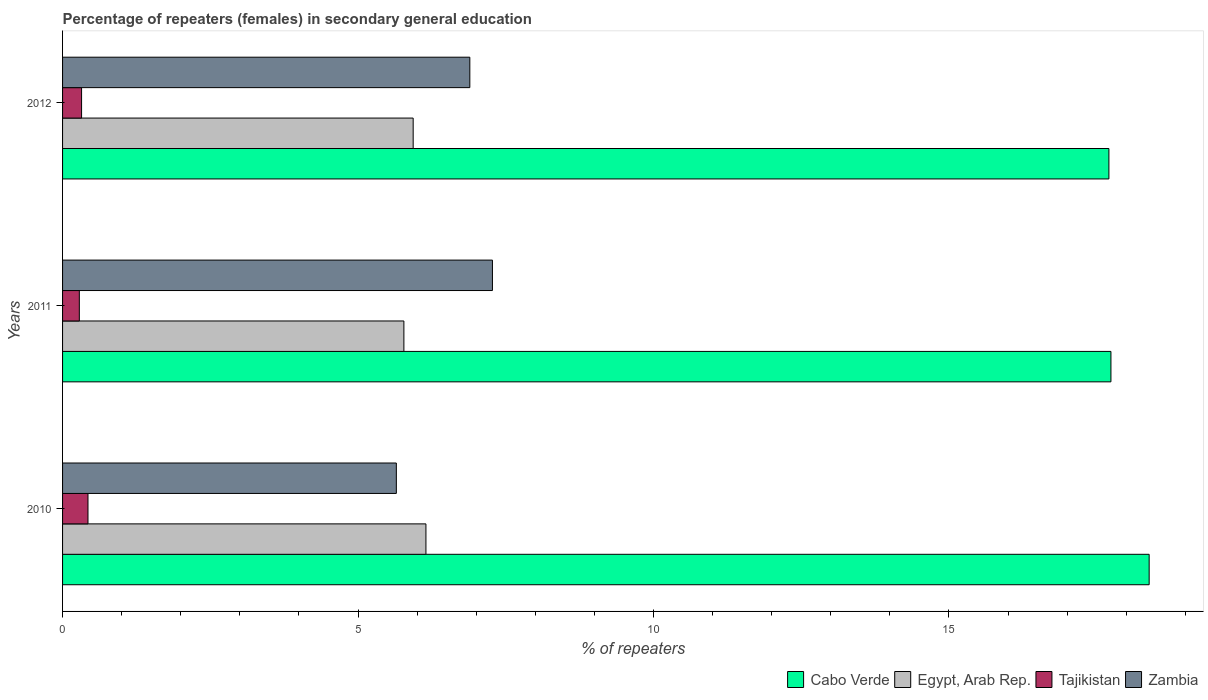How many groups of bars are there?
Make the answer very short. 3. Are the number of bars per tick equal to the number of legend labels?
Give a very brief answer. Yes. In how many cases, is the number of bars for a given year not equal to the number of legend labels?
Your answer should be compact. 0. What is the percentage of female repeaters in Cabo Verde in 2011?
Offer a very short reply. 17.74. Across all years, what is the maximum percentage of female repeaters in Tajikistan?
Your response must be concise. 0.43. Across all years, what is the minimum percentage of female repeaters in Egypt, Arab Rep.?
Provide a short and direct response. 5.78. What is the total percentage of female repeaters in Tajikistan in the graph?
Your answer should be compact. 1.04. What is the difference between the percentage of female repeaters in Tajikistan in 2010 and that in 2011?
Provide a succinct answer. 0.15. What is the difference between the percentage of female repeaters in Egypt, Arab Rep. in 2010 and the percentage of female repeaters in Zambia in 2012?
Your answer should be compact. -0.74. What is the average percentage of female repeaters in Tajikistan per year?
Provide a succinct answer. 0.35. In the year 2011, what is the difference between the percentage of female repeaters in Egypt, Arab Rep. and percentage of female repeaters in Tajikistan?
Your answer should be compact. 5.49. In how many years, is the percentage of female repeaters in Tajikistan greater than 14 %?
Ensure brevity in your answer.  0. What is the ratio of the percentage of female repeaters in Cabo Verde in 2010 to that in 2011?
Provide a succinct answer. 1.04. Is the percentage of female repeaters in Tajikistan in 2010 less than that in 2011?
Give a very brief answer. No. Is the difference between the percentage of female repeaters in Egypt, Arab Rep. in 2011 and 2012 greater than the difference between the percentage of female repeaters in Tajikistan in 2011 and 2012?
Your response must be concise. No. What is the difference between the highest and the second highest percentage of female repeaters in Tajikistan?
Offer a very short reply. 0.11. What is the difference between the highest and the lowest percentage of female repeaters in Zambia?
Your answer should be compact. 1.63. In how many years, is the percentage of female repeaters in Cabo Verde greater than the average percentage of female repeaters in Cabo Verde taken over all years?
Give a very brief answer. 1. Is it the case that in every year, the sum of the percentage of female repeaters in Egypt, Arab Rep. and percentage of female repeaters in Zambia is greater than the sum of percentage of female repeaters in Cabo Verde and percentage of female repeaters in Tajikistan?
Your answer should be compact. Yes. What does the 3rd bar from the top in 2012 represents?
Ensure brevity in your answer.  Egypt, Arab Rep. What does the 3rd bar from the bottom in 2012 represents?
Your answer should be very brief. Tajikistan. Is it the case that in every year, the sum of the percentage of female repeaters in Tajikistan and percentage of female repeaters in Cabo Verde is greater than the percentage of female repeaters in Egypt, Arab Rep.?
Your response must be concise. Yes. How many bars are there?
Offer a very short reply. 12. How many years are there in the graph?
Your answer should be compact. 3. What is the difference between two consecutive major ticks on the X-axis?
Ensure brevity in your answer.  5. Are the values on the major ticks of X-axis written in scientific E-notation?
Your answer should be compact. No. Does the graph contain any zero values?
Provide a succinct answer. No. What is the title of the graph?
Offer a terse response. Percentage of repeaters (females) in secondary general education. Does "European Union" appear as one of the legend labels in the graph?
Keep it short and to the point. No. What is the label or title of the X-axis?
Your answer should be very brief. % of repeaters. What is the label or title of the Y-axis?
Provide a succinct answer. Years. What is the % of repeaters in Cabo Verde in 2010?
Offer a very short reply. 18.39. What is the % of repeaters in Egypt, Arab Rep. in 2010?
Make the answer very short. 6.15. What is the % of repeaters in Tajikistan in 2010?
Make the answer very short. 0.43. What is the % of repeaters in Zambia in 2010?
Provide a short and direct response. 5.65. What is the % of repeaters of Cabo Verde in 2011?
Keep it short and to the point. 17.74. What is the % of repeaters in Egypt, Arab Rep. in 2011?
Your answer should be compact. 5.78. What is the % of repeaters in Tajikistan in 2011?
Your response must be concise. 0.28. What is the % of repeaters in Zambia in 2011?
Offer a terse response. 7.27. What is the % of repeaters of Cabo Verde in 2012?
Make the answer very short. 17.71. What is the % of repeaters of Egypt, Arab Rep. in 2012?
Make the answer very short. 5.93. What is the % of repeaters in Tajikistan in 2012?
Make the answer very short. 0.32. What is the % of repeaters in Zambia in 2012?
Keep it short and to the point. 6.89. Across all years, what is the maximum % of repeaters in Cabo Verde?
Provide a short and direct response. 18.39. Across all years, what is the maximum % of repeaters in Egypt, Arab Rep.?
Give a very brief answer. 6.15. Across all years, what is the maximum % of repeaters of Tajikistan?
Your answer should be very brief. 0.43. Across all years, what is the maximum % of repeaters in Zambia?
Provide a short and direct response. 7.27. Across all years, what is the minimum % of repeaters of Cabo Verde?
Keep it short and to the point. 17.71. Across all years, what is the minimum % of repeaters in Egypt, Arab Rep.?
Make the answer very short. 5.78. Across all years, what is the minimum % of repeaters of Tajikistan?
Provide a succinct answer. 0.28. Across all years, what is the minimum % of repeaters of Zambia?
Provide a succinct answer. 5.65. What is the total % of repeaters in Cabo Verde in the graph?
Make the answer very short. 53.84. What is the total % of repeaters in Egypt, Arab Rep. in the graph?
Give a very brief answer. 17.86. What is the total % of repeaters of Tajikistan in the graph?
Your answer should be very brief. 1.04. What is the total % of repeaters in Zambia in the graph?
Provide a succinct answer. 19.82. What is the difference between the % of repeaters of Cabo Verde in 2010 and that in 2011?
Keep it short and to the point. 0.65. What is the difference between the % of repeaters of Egypt, Arab Rep. in 2010 and that in 2011?
Ensure brevity in your answer.  0.37. What is the difference between the % of repeaters in Tajikistan in 2010 and that in 2011?
Make the answer very short. 0.15. What is the difference between the % of repeaters of Zambia in 2010 and that in 2011?
Your answer should be very brief. -1.63. What is the difference between the % of repeaters of Cabo Verde in 2010 and that in 2012?
Ensure brevity in your answer.  0.68. What is the difference between the % of repeaters in Egypt, Arab Rep. in 2010 and that in 2012?
Offer a terse response. 0.22. What is the difference between the % of repeaters of Tajikistan in 2010 and that in 2012?
Provide a succinct answer. 0.11. What is the difference between the % of repeaters in Zambia in 2010 and that in 2012?
Your response must be concise. -1.24. What is the difference between the % of repeaters in Cabo Verde in 2011 and that in 2012?
Give a very brief answer. 0.03. What is the difference between the % of repeaters in Egypt, Arab Rep. in 2011 and that in 2012?
Provide a succinct answer. -0.16. What is the difference between the % of repeaters in Tajikistan in 2011 and that in 2012?
Give a very brief answer. -0.04. What is the difference between the % of repeaters of Zambia in 2011 and that in 2012?
Your response must be concise. 0.38. What is the difference between the % of repeaters in Cabo Verde in 2010 and the % of repeaters in Egypt, Arab Rep. in 2011?
Make the answer very short. 12.61. What is the difference between the % of repeaters of Cabo Verde in 2010 and the % of repeaters of Tajikistan in 2011?
Offer a terse response. 18.1. What is the difference between the % of repeaters of Cabo Verde in 2010 and the % of repeaters of Zambia in 2011?
Provide a succinct answer. 11.11. What is the difference between the % of repeaters of Egypt, Arab Rep. in 2010 and the % of repeaters of Tajikistan in 2011?
Give a very brief answer. 5.87. What is the difference between the % of repeaters of Egypt, Arab Rep. in 2010 and the % of repeaters of Zambia in 2011?
Provide a short and direct response. -1.13. What is the difference between the % of repeaters in Tajikistan in 2010 and the % of repeaters in Zambia in 2011?
Keep it short and to the point. -6.84. What is the difference between the % of repeaters of Cabo Verde in 2010 and the % of repeaters of Egypt, Arab Rep. in 2012?
Ensure brevity in your answer.  12.46. What is the difference between the % of repeaters of Cabo Verde in 2010 and the % of repeaters of Tajikistan in 2012?
Offer a very short reply. 18.07. What is the difference between the % of repeaters of Cabo Verde in 2010 and the % of repeaters of Zambia in 2012?
Offer a very short reply. 11.5. What is the difference between the % of repeaters in Egypt, Arab Rep. in 2010 and the % of repeaters in Tajikistan in 2012?
Your answer should be very brief. 5.83. What is the difference between the % of repeaters of Egypt, Arab Rep. in 2010 and the % of repeaters of Zambia in 2012?
Keep it short and to the point. -0.74. What is the difference between the % of repeaters in Tajikistan in 2010 and the % of repeaters in Zambia in 2012?
Your answer should be compact. -6.46. What is the difference between the % of repeaters in Cabo Verde in 2011 and the % of repeaters in Egypt, Arab Rep. in 2012?
Offer a terse response. 11.81. What is the difference between the % of repeaters in Cabo Verde in 2011 and the % of repeaters in Tajikistan in 2012?
Keep it short and to the point. 17.42. What is the difference between the % of repeaters of Cabo Verde in 2011 and the % of repeaters of Zambia in 2012?
Your answer should be compact. 10.85. What is the difference between the % of repeaters of Egypt, Arab Rep. in 2011 and the % of repeaters of Tajikistan in 2012?
Provide a short and direct response. 5.45. What is the difference between the % of repeaters of Egypt, Arab Rep. in 2011 and the % of repeaters of Zambia in 2012?
Provide a succinct answer. -1.12. What is the difference between the % of repeaters of Tajikistan in 2011 and the % of repeaters of Zambia in 2012?
Ensure brevity in your answer.  -6.61. What is the average % of repeaters in Cabo Verde per year?
Your response must be concise. 17.95. What is the average % of repeaters of Egypt, Arab Rep. per year?
Give a very brief answer. 5.95. What is the average % of repeaters of Tajikistan per year?
Your answer should be very brief. 0.35. What is the average % of repeaters of Zambia per year?
Ensure brevity in your answer.  6.61. In the year 2010, what is the difference between the % of repeaters in Cabo Verde and % of repeaters in Egypt, Arab Rep.?
Keep it short and to the point. 12.24. In the year 2010, what is the difference between the % of repeaters in Cabo Verde and % of repeaters in Tajikistan?
Keep it short and to the point. 17.96. In the year 2010, what is the difference between the % of repeaters of Cabo Verde and % of repeaters of Zambia?
Make the answer very short. 12.74. In the year 2010, what is the difference between the % of repeaters in Egypt, Arab Rep. and % of repeaters in Tajikistan?
Keep it short and to the point. 5.72. In the year 2010, what is the difference between the % of repeaters of Egypt, Arab Rep. and % of repeaters of Zambia?
Your response must be concise. 0.5. In the year 2010, what is the difference between the % of repeaters in Tajikistan and % of repeaters in Zambia?
Ensure brevity in your answer.  -5.22. In the year 2011, what is the difference between the % of repeaters of Cabo Verde and % of repeaters of Egypt, Arab Rep.?
Give a very brief answer. 11.97. In the year 2011, what is the difference between the % of repeaters of Cabo Verde and % of repeaters of Tajikistan?
Make the answer very short. 17.46. In the year 2011, what is the difference between the % of repeaters of Cabo Verde and % of repeaters of Zambia?
Make the answer very short. 10.47. In the year 2011, what is the difference between the % of repeaters in Egypt, Arab Rep. and % of repeaters in Tajikistan?
Give a very brief answer. 5.49. In the year 2011, what is the difference between the % of repeaters in Egypt, Arab Rep. and % of repeaters in Zambia?
Your answer should be compact. -1.5. In the year 2011, what is the difference between the % of repeaters in Tajikistan and % of repeaters in Zambia?
Offer a very short reply. -6.99. In the year 2012, what is the difference between the % of repeaters of Cabo Verde and % of repeaters of Egypt, Arab Rep.?
Offer a terse response. 11.77. In the year 2012, what is the difference between the % of repeaters of Cabo Verde and % of repeaters of Tajikistan?
Offer a very short reply. 17.39. In the year 2012, what is the difference between the % of repeaters in Cabo Verde and % of repeaters in Zambia?
Your answer should be very brief. 10.81. In the year 2012, what is the difference between the % of repeaters of Egypt, Arab Rep. and % of repeaters of Tajikistan?
Your response must be concise. 5.61. In the year 2012, what is the difference between the % of repeaters in Egypt, Arab Rep. and % of repeaters in Zambia?
Your response must be concise. -0.96. In the year 2012, what is the difference between the % of repeaters of Tajikistan and % of repeaters of Zambia?
Keep it short and to the point. -6.57. What is the ratio of the % of repeaters of Cabo Verde in 2010 to that in 2011?
Make the answer very short. 1.04. What is the ratio of the % of repeaters in Egypt, Arab Rep. in 2010 to that in 2011?
Offer a terse response. 1.06. What is the ratio of the % of repeaters of Tajikistan in 2010 to that in 2011?
Your answer should be very brief. 1.52. What is the ratio of the % of repeaters in Zambia in 2010 to that in 2011?
Ensure brevity in your answer.  0.78. What is the ratio of the % of repeaters of Egypt, Arab Rep. in 2010 to that in 2012?
Give a very brief answer. 1.04. What is the ratio of the % of repeaters in Tajikistan in 2010 to that in 2012?
Your answer should be compact. 1.34. What is the ratio of the % of repeaters of Zambia in 2010 to that in 2012?
Provide a succinct answer. 0.82. What is the ratio of the % of repeaters of Cabo Verde in 2011 to that in 2012?
Give a very brief answer. 1. What is the ratio of the % of repeaters of Egypt, Arab Rep. in 2011 to that in 2012?
Offer a terse response. 0.97. What is the ratio of the % of repeaters in Tajikistan in 2011 to that in 2012?
Offer a very short reply. 0.88. What is the ratio of the % of repeaters in Zambia in 2011 to that in 2012?
Keep it short and to the point. 1.06. What is the difference between the highest and the second highest % of repeaters of Cabo Verde?
Offer a very short reply. 0.65. What is the difference between the highest and the second highest % of repeaters of Egypt, Arab Rep.?
Your answer should be very brief. 0.22. What is the difference between the highest and the second highest % of repeaters of Tajikistan?
Keep it short and to the point. 0.11. What is the difference between the highest and the second highest % of repeaters in Zambia?
Offer a terse response. 0.38. What is the difference between the highest and the lowest % of repeaters of Cabo Verde?
Ensure brevity in your answer.  0.68. What is the difference between the highest and the lowest % of repeaters of Egypt, Arab Rep.?
Make the answer very short. 0.37. What is the difference between the highest and the lowest % of repeaters in Tajikistan?
Offer a very short reply. 0.15. What is the difference between the highest and the lowest % of repeaters of Zambia?
Ensure brevity in your answer.  1.63. 